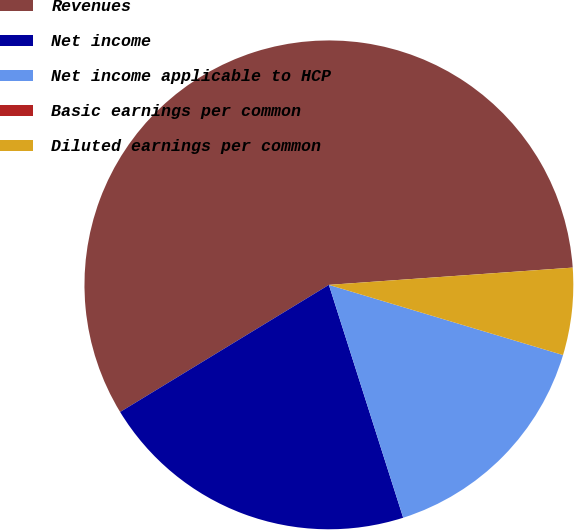<chart> <loc_0><loc_0><loc_500><loc_500><pie_chart><fcel>Revenues<fcel>Net income<fcel>Net income applicable to HCP<fcel>Basic earnings per common<fcel>Diluted earnings per common<nl><fcel>57.58%<fcel>21.21%<fcel>15.45%<fcel>0.0%<fcel>5.76%<nl></chart> 